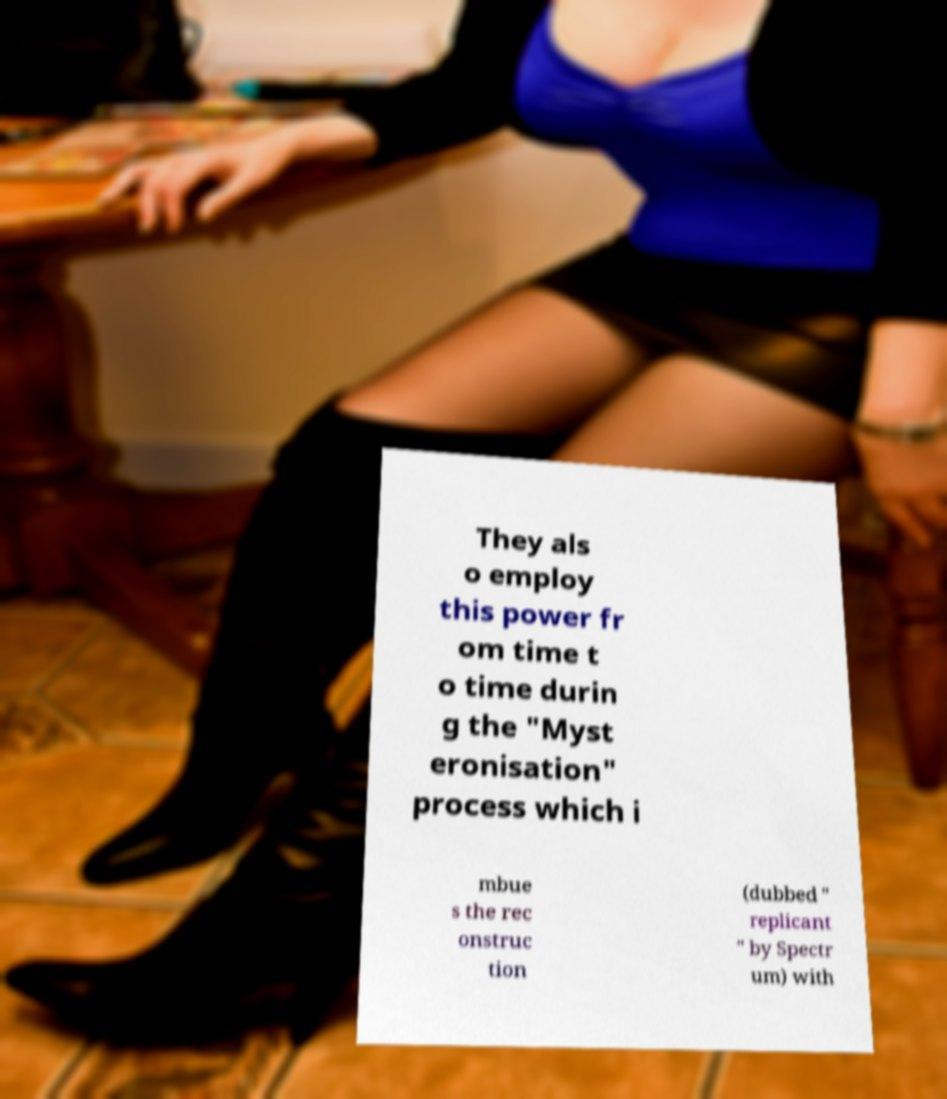Can you read and provide the text displayed in the image?This photo seems to have some interesting text. Can you extract and type it out for me? They als o employ this power fr om time t o time durin g the "Myst eronisation" process which i mbue s the rec onstruc tion (dubbed " replicant " by Spectr um) with 